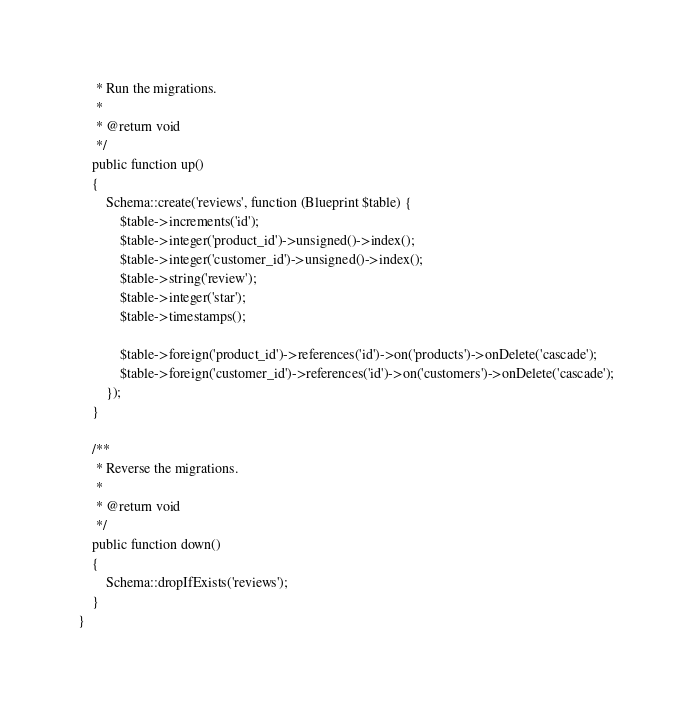<code> <loc_0><loc_0><loc_500><loc_500><_PHP_>     * Run the migrations.
     *
     * @return void
     */
    public function up()
    {
        Schema::create('reviews', function (Blueprint $table) {
            $table->increments('id');
            $table->integer('product_id')->unsigned()->index();
            $table->integer('customer_id')->unsigned()->index();
            $table->string('review');
            $table->integer('star');
            $table->timestamps();

            $table->foreign('product_id')->references('id')->on('products')->onDelete('cascade');
            $table->foreign('customer_id')->references('id')->on('customers')->onDelete('cascade');
        });
    }

    /**
     * Reverse the migrations.
     *
     * @return void
     */
    public function down()
    {
        Schema::dropIfExists('reviews');
    }
}
</code> 